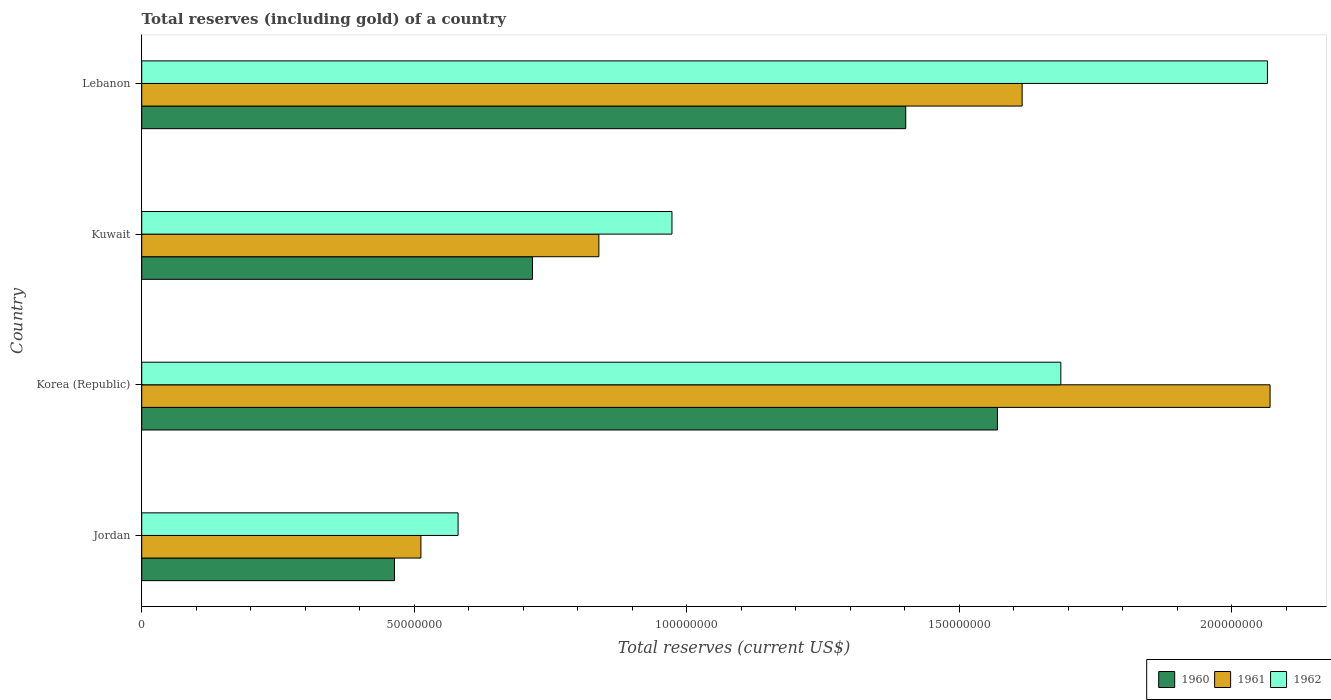How many different coloured bars are there?
Make the answer very short. 3. How many groups of bars are there?
Offer a terse response. 4. How many bars are there on the 1st tick from the top?
Provide a short and direct response. 3. What is the label of the 4th group of bars from the top?
Your response must be concise. Jordan. In how many cases, is the number of bars for a given country not equal to the number of legend labels?
Keep it short and to the point. 0. What is the total reserves (including gold) in 1962 in Jordan?
Keep it short and to the point. 5.80e+07. Across all countries, what is the maximum total reserves (including gold) in 1961?
Provide a short and direct response. 2.07e+08. Across all countries, what is the minimum total reserves (including gold) in 1961?
Provide a short and direct response. 5.12e+07. In which country was the total reserves (including gold) in 1960 maximum?
Provide a succinct answer. Korea (Republic). In which country was the total reserves (including gold) in 1962 minimum?
Provide a short and direct response. Jordan. What is the total total reserves (including gold) in 1962 in the graph?
Offer a terse response. 5.31e+08. What is the difference between the total reserves (including gold) in 1960 in Korea (Republic) and that in Kuwait?
Your answer should be very brief. 8.53e+07. What is the difference between the total reserves (including gold) in 1961 in Kuwait and the total reserves (including gold) in 1962 in Korea (Republic)?
Offer a very short reply. -8.48e+07. What is the average total reserves (including gold) in 1961 per country?
Provide a succinct answer. 1.26e+08. What is the difference between the total reserves (including gold) in 1960 and total reserves (including gold) in 1962 in Korea (Republic)?
Ensure brevity in your answer.  -1.16e+07. What is the ratio of the total reserves (including gold) in 1962 in Jordan to that in Lebanon?
Keep it short and to the point. 0.28. Is the total reserves (including gold) in 1961 in Korea (Republic) less than that in Lebanon?
Offer a terse response. No. What is the difference between the highest and the second highest total reserves (including gold) in 1960?
Make the answer very short. 1.68e+07. What is the difference between the highest and the lowest total reserves (including gold) in 1962?
Provide a short and direct response. 1.49e+08. In how many countries, is the total reserves (including gold) in 1961 greater than the average total reserves (including gold) in 1961 taken over all countries?
Provide a succinct answer. 2. Is the sum of the total reserves (including gold) in 1962 in Jordan and Korea (Republic) greater than the maximum total reserves (including gold) in 1960 across all countries?
Keep it short and to the point. Yes. What does the 2nd bar from the top in Jordan represents?
Keep it short and to the point. 1961. How many countries are there in the graph?
Your answer should be very brief. 4. Are the values on the major ticks of X-axis written in scientific E-notation?
Offer a terse response. No. Does the graph contain any zero values?
Offer a very short reply. No. Where does the legend appear in the graph?
Give a very brief answer. Bottom right. How are the legend labels stacked?
Make the answer very short. Horizontal. What is the title of the graph?
Your response must be concise. Total reserves (including gold) of a country. Does "1992" appear as one of the legend labels in the graph?
Your answer should be compact. No. What is the label or title of the X-axis?
Provide a succinct answer. Total reserves (current US$). What is the Total reserves (current US$) in 1960 in Jordan?
Your answer should be compact. 4.64e+07. What is the Total reserves (current US$) in 1961 in Jordan?
Your response must be concise. 5.12e+07. What is the Total reserves (current US$) of 1962 in Jordan?
Your answer should be very brief. 5.80e+07. What is the Total reserves (current US$) in 1960 in Korea (Republic)?
Offer a very short reply. 1.57e+08. What is the Total reserves (current US$) in 1961 in Korea (Republic)?
Offer a terse response. 2.07e+08. What is the Total reserves (current US$) of 1962 in Korea (Republic)?
Offer a terse response. 1.69e+08. What is the Total reserves (current US$) in 1960 in Kuwait?
Keep it short and to the point. 7.17e+07. What is the Total reserves (current US$) in 1961 in Kuwait?
Provide a short and direct response. 8.39e+07. What is the Total reserves (current US$) of 1962 in Kuwait?
Offer a very short reply. 9.73e+07. What is the Total reserves (current US$) of 1960 in Lebanon?
Your response must be concise. 1.40e+08. What is the Total reserves (current US$) in 1961 in Lebanon?
Provide a succinct answer. 1.62e+08. What is the Total reserves (current US$) in 1962 in Lebanon?
Offer a terse response. 2.07e+08. Across all countries, what is the maximum Total reserves (current US$) of 1960?
Offer a very short reply. 1.57e+08. Across all countries, what is the maximum Total reserves (current US$) in 1961?
Keep it short and to the point. 2.07e+08. Across all countries, what is the maximum Total reserves (current US$) of 1962?
Give a very brief answer. 2.07e+08. Across all countries, what is the minimum Total reserves (current US$) of 1960?
Your answer should be very brief. 4.64e+07. Across all countries, what is the minimum Total reserves (current US$) of 1961?
Offer a very short reply. 5.12e+07. Across all countries, what is the minimum Total reserves (current US$) in 1962?
Your answer should be very brief. 5.80e+07. What is the total Total reserves (current US$) of 1960 in the graph?
Provide a short and direct response. 4.15e+08. What is the total Total reserves (current US$) in 1961 in the graph?
Keep it short and to the point. 5.04e+08. What is the total Total reserves (current US$) of 1962 in the graph?
Ensure brevity in your answer.  5.31e+08. What is the difference between the Total reserves (current US$) in 1960 in Jordan and that in Korea (Republic)?
Give a very brief answer. -1.11e+08. What is the difference between the Total reserves (current US$) of 1961 in Jordan and that in Korea (Republic)?
Ensure brevity in your answer.  -1.56e+08. What is the difference between the Total reserves (current US$) in 1962 in Jordan and that in Korea (Republic)?
Offer a very short reply. -1.11e+08. What is the difference between the Total reserves (current US$) of 1960 in Jordan and that in Kuwait?
Offer a terse response. -2.53e+07. What is the difference between the Total reserves (current US$) of 1961 in Jordan and that in Kuwait?
Provide a short and direct response. -3.27e+07. What is the difference between the Total reserves (current US$) of 1962 in Jordan and that in Kuwait?
Provide a succinct answer. -3.92e+07. What is the difference between the Total reserves (current US$) in 1960 in Jordan and that in Lebanon?
Give a very brief answer. -9.38e+07. What is the difference between the Total reserves (current US$) in 1961 in Jordan and that in Lebanon?
Ensure brevity in your answer.  -1.10e+08. What is the difference between the Total reserves (current US$) of 1962 in Jordan and that in Lebanon?
Offer a terse response. -1.49e+08. What is the difference between the Total reserves (current US$) of 1960 in Korea (Republic) and that in Kuwait?
Ensure brevity in your answer.  8.53e+07. What is the difference between the Total reserves (current US$) of 1961 in Korea (Republic) and that in Kuwait?
Ensure brevity in your answer.  1.23e+08. What is the difference between the Total reserves (current US$) of 1962 in Korea (Republic) and that in Kuwait?
Provide a succinct answer. 7.14e+07. What is the difference between the Total reserves (current US$) in 1960 in Korea (Republic) and that in Lebanon?
Your answer should be compact. 1.68e+07. What is the difference between the Total reserves (current US$) in 1961 in Korea (Republic) and that in Lebanon?
Offer a very short reply. 4.55e+07. What is the difference between the Total reserves (current US$) of 1962 in Korea (Republic) and that in Lebanon?
Your answer should be very brief. -3.79e+07. What is the difference between the Total reserves (current US$) of 1960 in Kuwait and that in Lebanon?
Provide a short and direct response. -6.85e+07. What is the difference between the Total reserves (current US$) in 1961 in Kuwait and that in Lebanon?
Your answer should be very brief. -7.77e+07. What is the difference between the Total reserves (current US$) in 1962 in Kuwait and that in Lebanon?
Give a very brief answer. -1.09e+08. What is the difference between the Total reserves (current US$) in 1960 in Jordan and the Total reserves (current US$) in 1961 in Korea (Republic)?
Offer a terse response. -1.61e+08. What is the difference between the Total reserves (current US$) of 1960 in Jordan and the Total reserves (current US$) of 1962 in Korea (Republic)?
Ensure brevity in your answer.  -1.22e+08. What is the difference between the Total reserves (current US$) in 1961 in Jordan and the Total reserves (current US$) in 1962 in Korea (Republic)?
Keep it short and to the point. -1.17e+08. What is the difference between the Total reserves (current US$) in 1960 in Jordan and the Total reserves (current US$) in 1961 in Kuwait?
Provide a succinct answer. -3.75e+07. What is the difference between the Total reserves (current US$) in 1960 in Jordan and the Total reserves (current US$) in 1962 in Kuwait?
Your response must be concise. -5.09e+07. What is the difference between the Total reserves (current US$) in 1961 in Jordan and the Total reserves (current US$) in 1962 in Kuwait?
Your answer should be very brief. -4.61e+07. What is the difference between the Total reserves (current US$) in 1960 in Jordan and the Total reserves (current US$) in 1961 in Lebanon?
Make the answer very short. -1.15e+08. What is the difference between the Total reserves (current US$) of 1960 in Jordan and the Total reserves (current US$) of 1962 in Lebanon?
Ensure brevity in your answer.  -1.60e+08. What is the difference between the Total reserves (current US$) in 1961 in Jordan and the Total reserves (current US$) in 1962 in Lebanon?
Provide a succinct answer. -1.55e+08. What is the difference between the Total reserves (current US$) of 1960 in Korea (Republic) and the Total reserves (current US$) of 1961 in Kuwait?
Give a very brief answer. 7.31e+07. What is the difference between the Total reserves (current US$) of 1960 in Korea (Republic) and the Total reserves (current US$) of 1962 in Kuwait?
Offer a very short reply. 5.97e+07. What is the difference between the Total reserves (current US$) in 1961 in Korea (Republic) and the Total reserves (current US$) in 1962 in Kuwait?
Your answer should be very brief. 1.10e+08. What is the difference between the Total reserves (current US$) in 1960 in Korea (Republic) and the Total reserves (current US$) in 1961 in Lebanon?
Keep it short and to the point. -4.54e+06. What is the difference between the Total reserves (current US$) of 1960 in Korea (Republic) and the Total reserves (current US$) of 1962 in Lebanon?
Give a very brief answer. -4.95e+07. What is the difference between the Total reserves (current US$) in 1961 in Korea (Republic) and the Total reserves (current US$) in 1962 in Lebanon?
Keep it short and to the point. 4.83e+05. What is the difference between the Total reserves (current US$) in 1960 in Kuwait and the Total reserves (current US$) in 1961 in Lebanon?
Make the answer very short. -8.99e+07. What is the difference between the Total reserves (current US$) of 1960 in Kuwait and the Total reserves (current US$) of 1962 in Lebanon?
Your answer should be compact. -1.35e+08. What is the difference between the Total reserves (current US$) in 1961 in Kuwait and the Total reserves (current US$) in 1962 in Lebanon?
Your response must be concise. -1.23e+08. What is the average Total reserves (current US$) of 1960 per country?
Offer a very short reply. 1.04e+08. What is the average Total reserves (current US$) in 1961 per country?
Make the answer very short. 1.26e+08. What is the average Total reserves (current US$) in 1962 per country?
Provide a succinct answer. 1.33e+08. What is the difference between the Total reserves (current US$) of 1960 and Total reserves (current US$) of 1961 in Jordan?
Your answer should be very brief. -4.85e+06. What is the difference between the Total reserves (current US$) of 1960 and Total reserves (current US$) of 1962 in Jordan?
Your answer should be very brief. -1.17e+07. What is the difference between the Total reserves (current US$) of 1961 and Total reserves (current US$) of 1962 in Jordan?
Give a very brief answer. -6.82e+06. What is the difference between the Total reserves (current US$) in 1960 and Total reserves (current US$) in 1961 in Korea (Republic)?
Your answer should be very brief. -5.00e+07. What is the difference between the Total reserves (current US$) in 1960 and Total reserves (current US$) in 1962 in Korea (Republic)?
Offer a terse response. -1.16e+07. What is the difference between the Total reserves (current US$) of 1961 and Total reserves (current US$) of 1962 in Korea (Republic)?
Offer a very short reply. 3.84e+07. What is the difference between the Total reserves (current US$) in 1960 and Total reserves (current US$) in 1961 in Kuwait?
Keep it short and to the point. -1.22e+07. What is the difference between the Total reserves (current US$) in 1960 and Total reserves (current US$) in 1962 in Kuwait?
Ensure brevity in your answer.  -2.56e+07. What is the difference between the Total reserves (current US$) in 1961 and Total reserves (current US$) in 1962 in Kuwait?
Keep it short and to the point. -1.34e+07. What is the difference between the Total reserves (current US$) of 1960 and Total reserves (current US$) of 1961 in Lebanon?
Offer a terse response. -2.14e+07. What is the difference between the Total reserves (current US$) in 1960 and Total reserves (current US$) in 1962 in Lebanon?
Your answer should be compact. -6.64e+07. What is the difference between the Total reserves (current US$) in 1961 and Total reserves (current US$) in 1962 in Lebanon?
Your answer should be compact. -4.50e+07. What is the ratio of the Total reserves (current US$) of 1960 in Jordan to that in Korea (Republic)?
Your response must be concise. 0.3. What is the ratio of the Total reserves (current US$) in 1961 in Jordan to that in Korea (Republic)?
Your response must be concise. 0.25. What is the ratio of the Total reserves (current US$) in 1962 in Jordan to that in Korea (Republic)?
Give a very brief answer. 0.34. What is the ratio of the Total reserves (current US$) in 1960 in Jordan to that in Kuwait?
Keep it short and to the point. 0.65. What is the ratio of the Total reserves (current US$) of 1961 in Jordan to that in Kuwait?
Offer a very short reply. 0.61. What is the ratio of the Total reserves (current US$) of 1962 in Jordan to that in Kuwait?
Ensure brevity in your answer.  0.6. What is the ratio of the Total reserves (current US$) of 1960 in Jordan to that in Lebanon?
Give a very brief answer. 0.33. What is the ratio of the Total reserves (current US$) in 1961 in Jordan to that in Lebanon?
Provide a short and direct response. 0.32. What is the ratio of the Total reserves (current US$) of 1962 in Jordan to that in Lebanon?
Make the answer very short. 0.28. What is the ratio of the Total reserves (current US$) in 1960 in Korea (Republic) to that in Kuwait?
Provide a succinct answer. 2.19. What is the ratio of the Total reserves (current US$) of 1961 in Korea (Republic) to that in Kuwait?
Your response must be concise. 2.47. What is the ratio of the Total reserves (current US$) of 1962 in Korea (Republic) to that in Kuwait?
Offer a terse response. 1.73. What is the ratio of the Total reserves (current US$) of 1960 in Korea (Republic) to that in Lebanon?
Offer a terse response. 1.12. What is the ratio of the Total reserves (current US$) in 1961 in Korea (Republic) to that in Lebanon?
Make the answer very short. 1.28. What is the ratio of the Total reserves (current US$) of 1962 in Korea (Republic) to that in Lebanon?
Give a very brief answer. 0.82. What is the ratio of the Total reserves (current US$) in 1960 in Kuwait to that in Lebanon?
Your answer should be very brief. 0.51. What is the ratio of the Total reserves (current US$) of 1961 in Kuwait to that in Lebanon?
Your answer should be very brief. 0.52. What is the ratio of the Total reserves (current US$) of 1962 in Kuwait to that in Lebanon?
Keep it short and to the point. 0.47. What is the difference between the highest and the second highest Total reserves (current US$) of 1960?
Provide a short and direct response. 1.68e+07. What is the difference between the highest and the second highest Total reserves (current US$) in 1961?
Give a very brief answer. 4.55e+07. What is the difference between the highest and the second highest Total reserves (current US$) in 1962?
Make the answer very short. 3.79e+07. What is the difference between the highest and the lowest Total reserves (current US$) in 1960?
Your answer should be compact. 1.11e+08. What is the difference between the highest and the lowest Total reserves (current US$) in 1961?
Your answer should be compact. 1.56e+08. What is the difference between the highest and the lowest Total reserves (current US$) of 1962?
Your answer should be compact. 1.49e+08. 